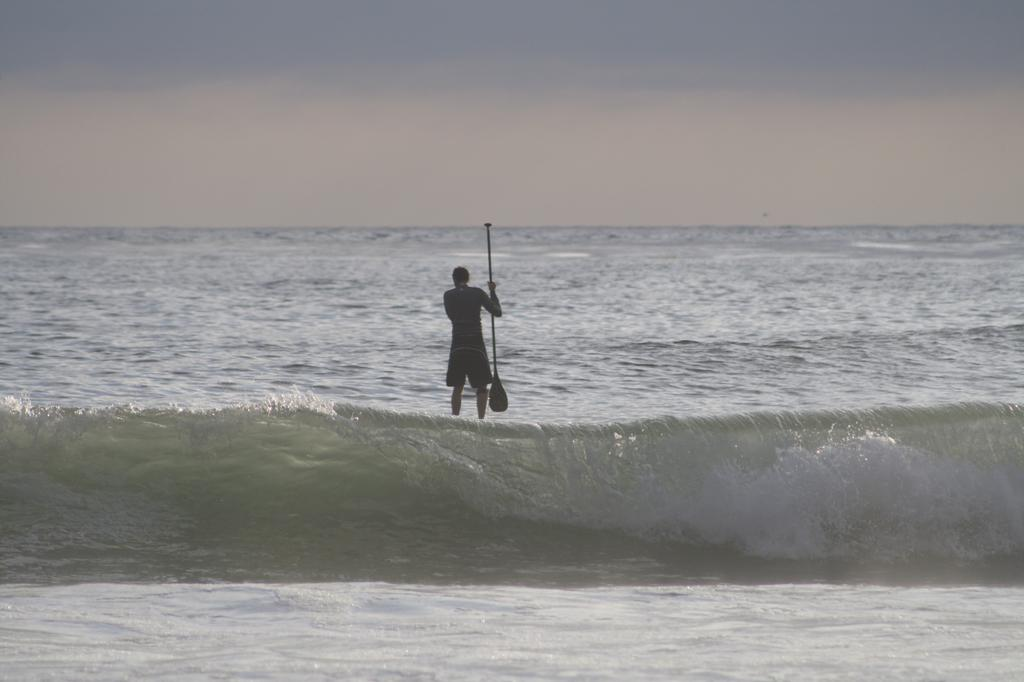What is the person in the image doing? The person is standing in the sea. What is the person holding in the image? The person is holding an object. What can be seen in the background of the image? The sky is visible in the background of the image. What type of bear can be seen swimming in the sea in the image? There is no bear present in the image; it features a person standing in the sea. Can you tell me where the lamp is located in the image? There is no lamp present in the image. 